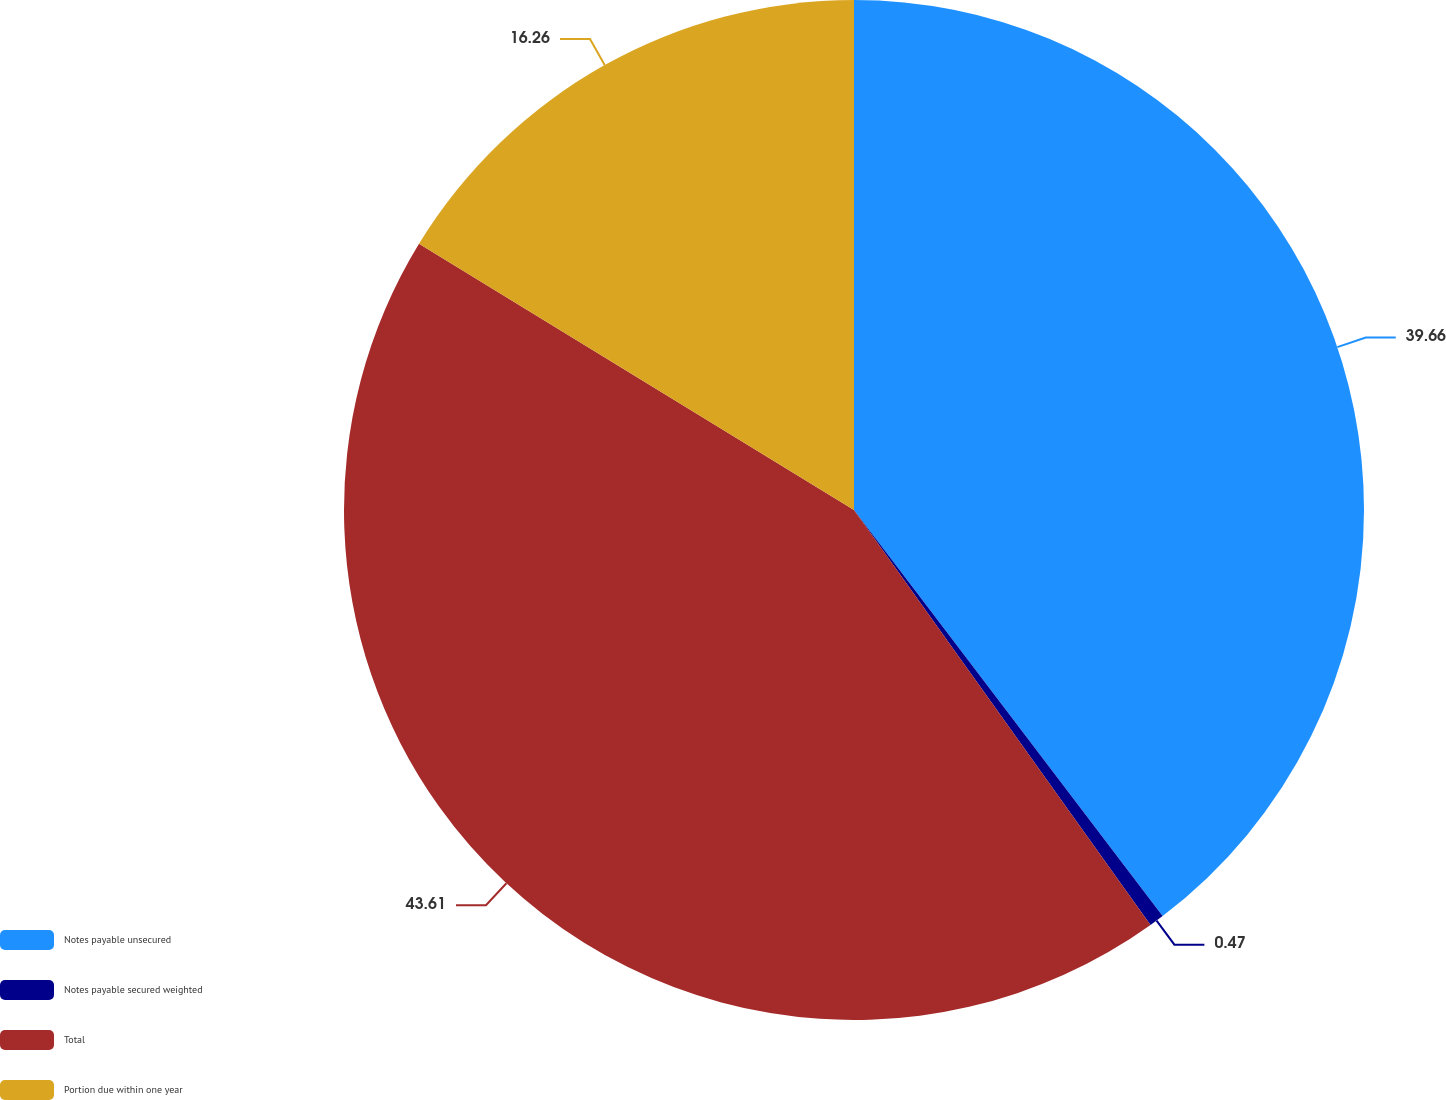<chart> <loc_0><loc_0><loc_500><loc_500><pie_chart><fcel>Notes payable unsecured<fcel>Notes payable secured weighted<fcel>Total<fcel>Portion due within one year<nl><fcel>39.66%<fcel>0.47%<fcel>43.62%<fcel>16.26%<nl></chart> 